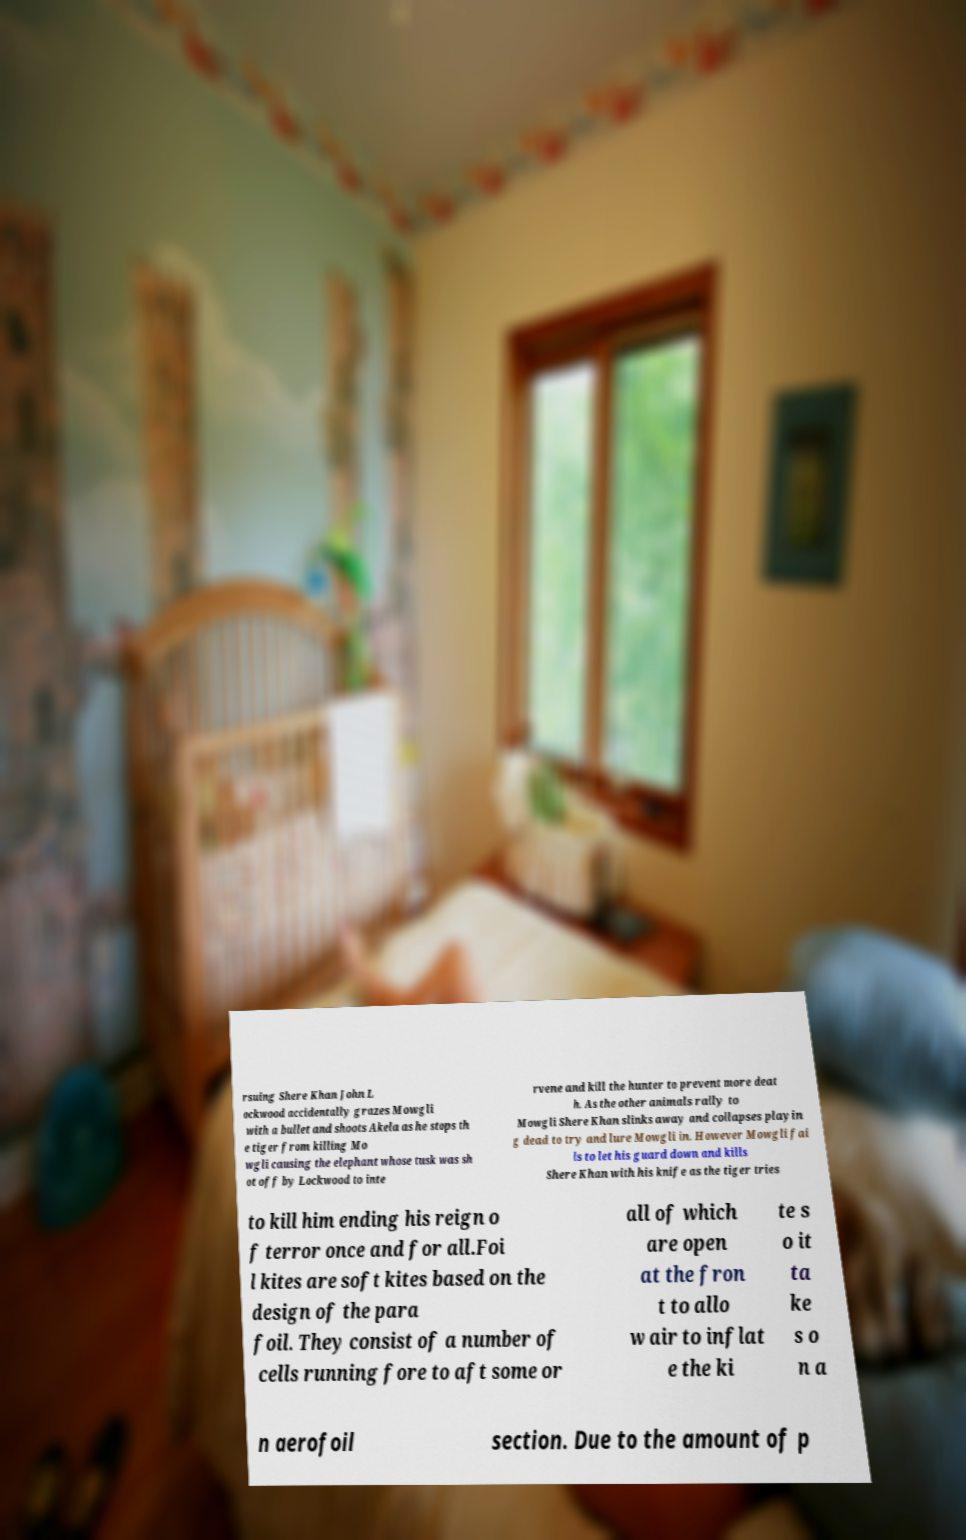Please read and relay the text visible in this image. What does it say? rsuing Shere Khan John L ockwood accidentally grazes Mowgli with a bullet and shoots Akela as he stops th e tiger from killing Mo wgli causing the elephant whose tusk was sh ot off by Lockwood to inte rvene and kill the hunter to prevent more deat h. As the other animals rally to Mowgli Shere Khan slinks away and collapses playin g dead to try and lure Mowgli in. However Mowgli fai ls to let his guard down and kills Shere Khan with his knife as the tiger tries to kill him ending his reign o f terror once and for all.Foi l kites are soft kites based on the design of the para foil. They consist of a number of cells running fore to aft some or all of which are open at the fron t to allo w air to inflat e the ki te s o it ta ke s o n a n aerofoil section. Due to the amount of p 